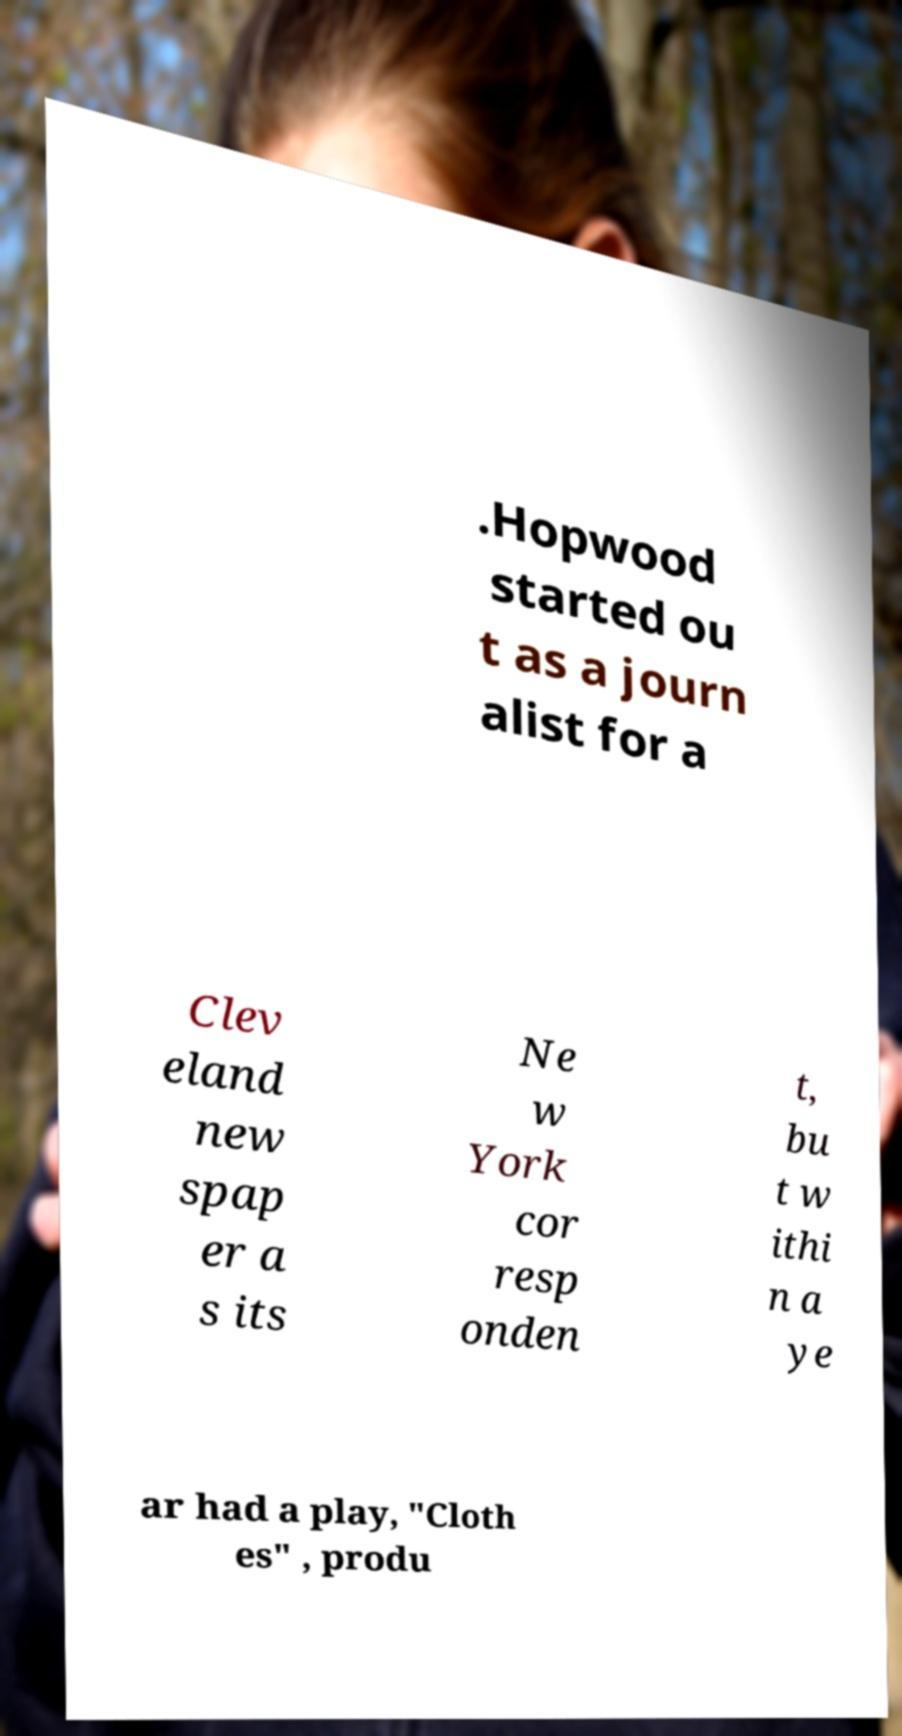There's text embedded in this image that I need extracted. Can you transcribe it verbatim? .Hopwood started ou t as a journ alist for a Clev eland new spap er a s its Ne w York cor resp onden t, bu t w ithi n a ye ar had a play, "Cloth es" , produ 